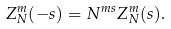<formula> <loc_0><loc_0><loc_500><loc_500>Z ^ { m } _ { N } ( - s ) = N ^ { m s } Z ^ { m } _ { N } ( s ) .</formula> 